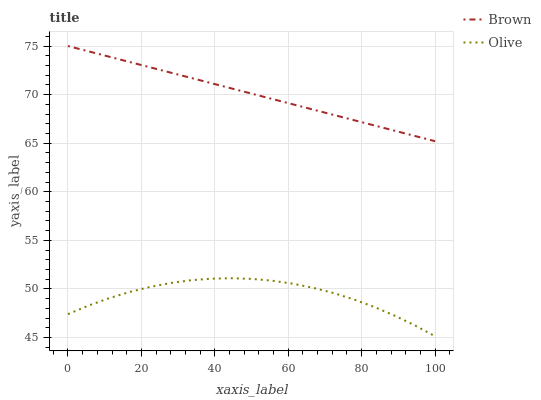Does Olive have the minimum area under the curve?
Answer yes or no. Yes. Does Brown have the maximum area under the curve?
Answer yes or no. Yes. Does Brown have the minimum area under the curve?
Answer yes or no. No. Is Brown the smoothest?
Answer yes or no. Yes. Is Olive the roughest?
Answer yes or no. Yes. Is Brown the roughest?
Answer yes or no. No. Does Olive have the lowest value?
Answer yes or no. Yes. Does Brown have the lowest value?
Answer yes or no. No. Does Brown have the highest value?
Answer yes or no. Yes. Is Olive less than Brown?
Answer yes or no. Yes. Is Brown greater than Olive?
Answer yes or no. Yes. Does Olive intersect Brown?
Answer yes or no. No. 